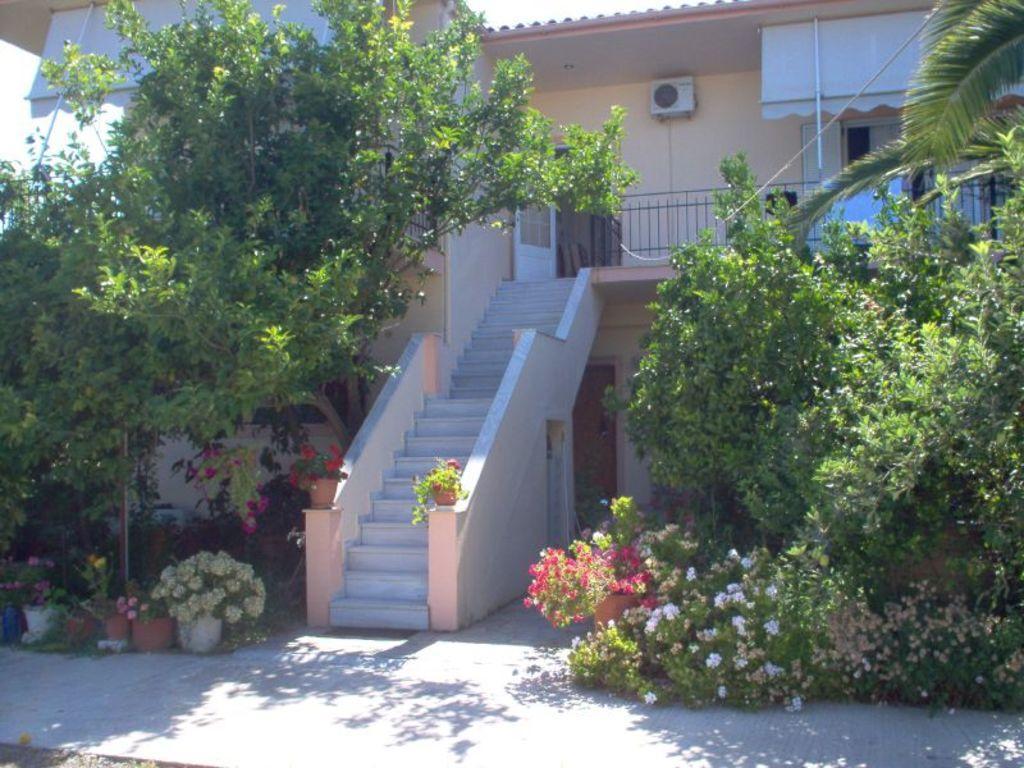In one or two sentences, can you explain what this image depicts? In this image we can see plants with flowers, trees, steps, railing, building, door, windows, poles, AC on the wall, objects and the sky. 